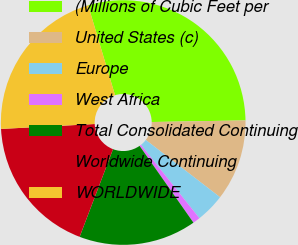Convert chart. <chart><loc_0><loc_0><loc_500><loc_500><pie_chart><fcel>(Millions of Cubic Feet per<fcel>United States (c)<fcel>Europe<fcel>West Africa<fcel>Total Consolidated Continuing<fcel>Worldwide Continuing<fcel>WORLDWIDE<nl><fcel>29.35%<fcel>10.73%<fcel>3.84%<fcel>0.97%<fcel>15.53%<fcel>18.37%<fcel>21.21%<nl></chart> 